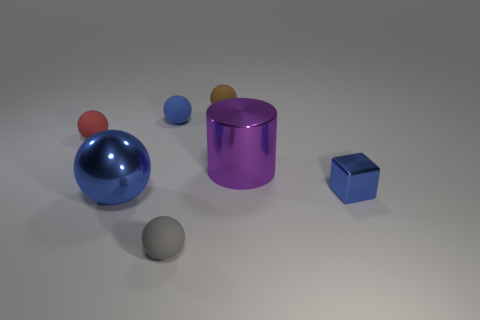What number of objects are things that are behind the big blue metallic object or tiny blue objects right of the gray object?
Offer a terse response. 5. How many blue rubber objects are the same shape as the large blue shiny thing?
Your answer should be very brief. 1. The block that is the same size as the brown rubber object is what color?
Provide a succinct answer. Blue. What color is the large metallic object to the right of the small thing that is in front of the object to the right of the purple shiny thing?
Provide a short and direct response. Purple. There is a purple thing; is its size the same as the blue sphere behind the purple metal object?
Offer a terse response. No. What number of things are either big brown matte blocks or tiny blue metal things?
Give a very brief answer. 1. Are there any brown spheres that have the same material as the red object?
Offer a very short reply. Yes. What size is the matte ball that is the same color as the small shiny cube?
Your answer should be very brief. Small. There is a big object behind the blue thing to the right of the tiny brown object; what is its color?
Your response must be concise. Purple. Does the gray matte ball have the same size as the red matte object?
Keep it short and to the point. Yes. 